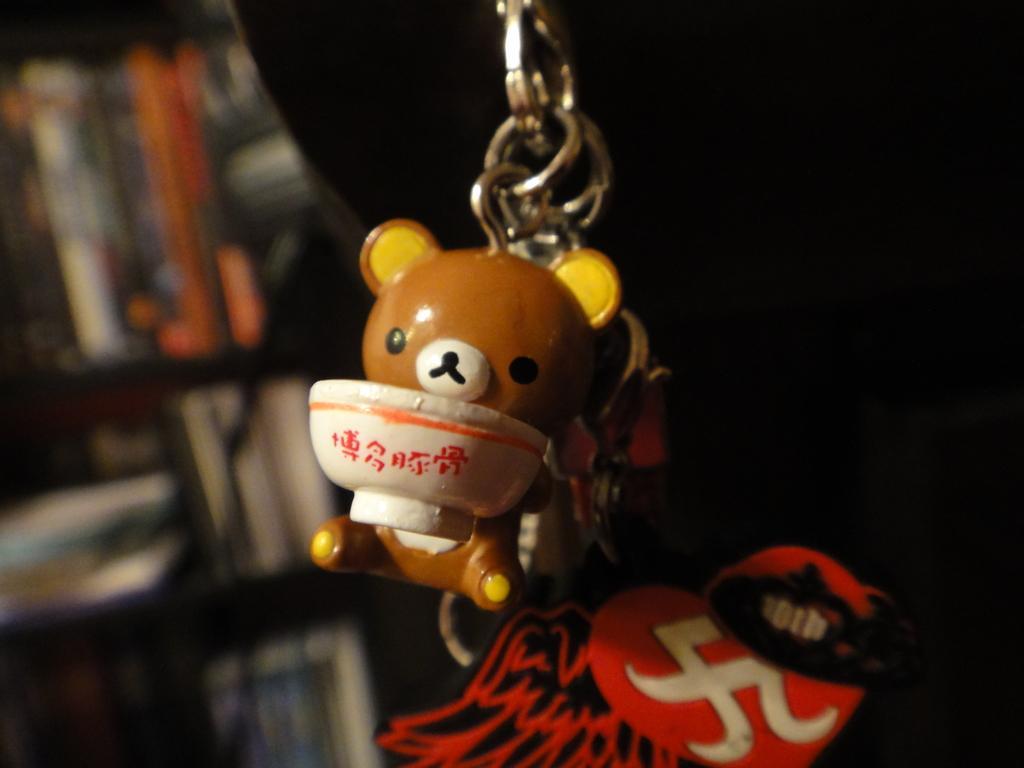In one or two sentences, can you explain what this image depicts? In this image we can see a toy keychain and books in the cup board. 